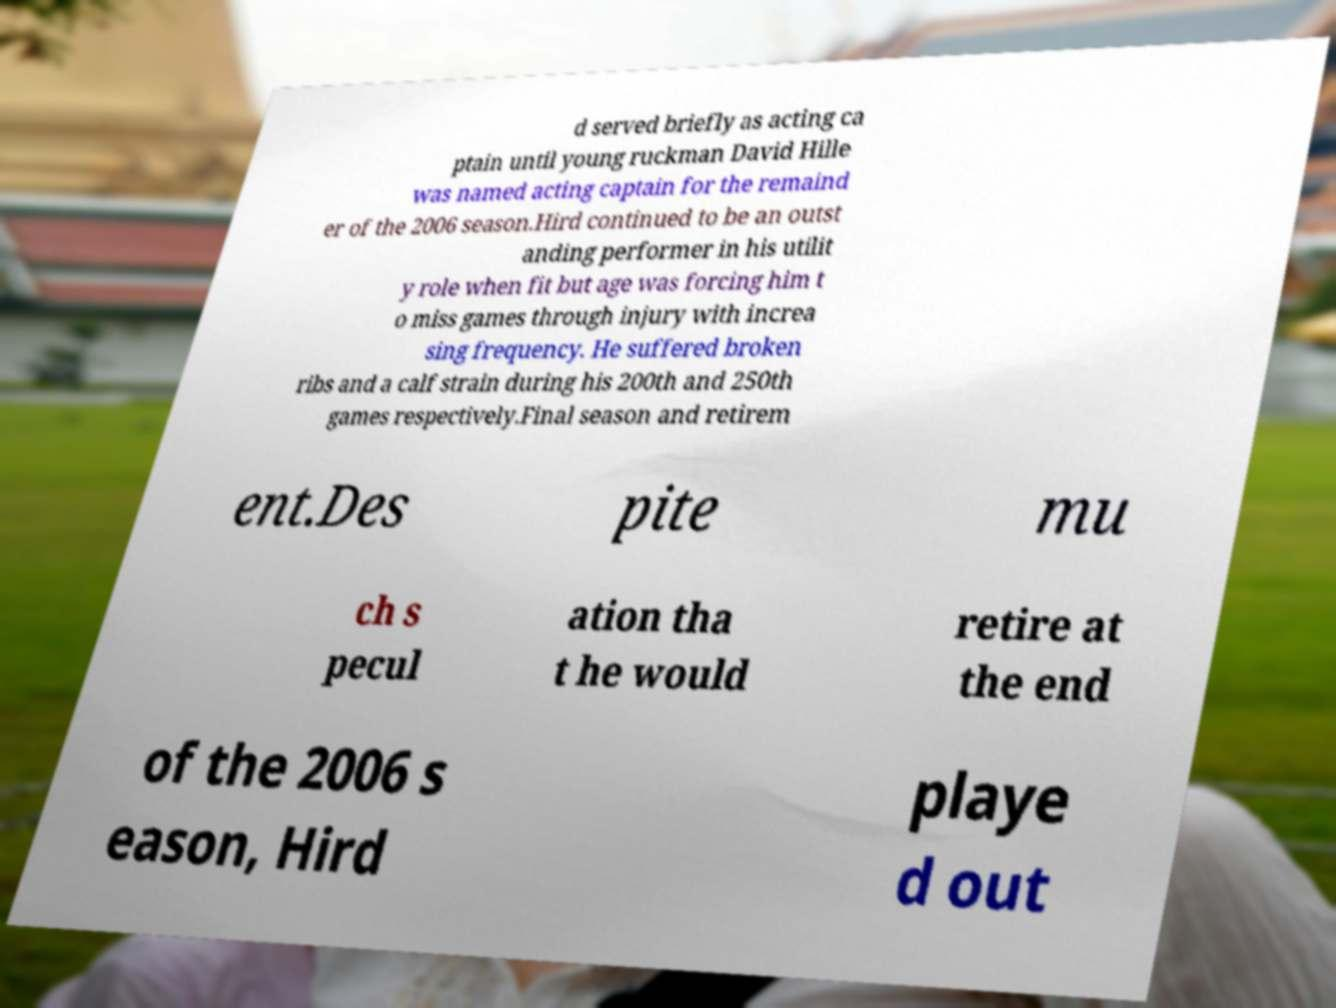What messages or text are displayed in this image? I need them in a readable, typed format. d served briefly as acting ca ptain until young ruckman David Hille was named acting captain for the remaind er of the 2006 season.Hird continued to be an outst anding performer in his utilit y role when fit but age was forcing him t o miss games through injury with increa sing frequency. He suffered broken ribs and a calf strain during his 200th and 250th games respectively.Final season and retirem ent.Des pite mu ch s pecul ation tha t he would retire at the end of the 2006 s eason, Hird playe d out 